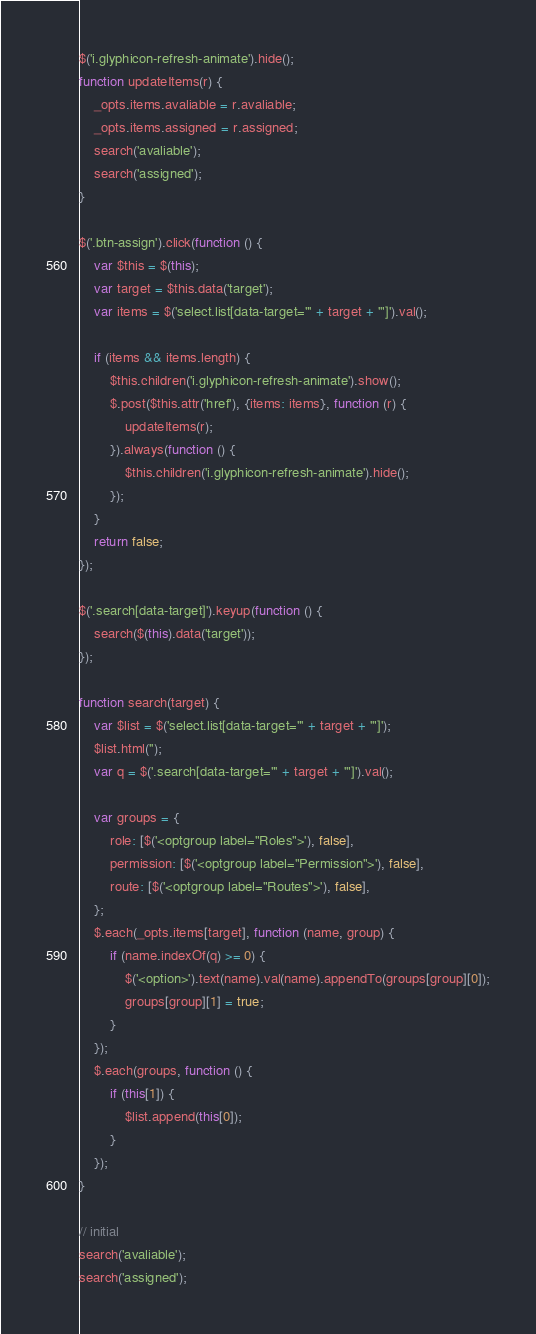<code> <loc_0><loc_0><loc_500><loc_500><_JavaScript_>$('i.glyphicon-refresh-animate').hide();
function updateItems(r) {
    _opts.items.avaliable = r.avaliable;
    _opts.items.assigned = r.assigned;
    search('avaliable');
    search('assigned');
}

$('.btn-assign').click(function () {
    var $this = $(this);
    var target = $this.data('target');
    var items = $('select.list[data-target="' + target + '"]').val();

    if (items && items.length) {
        $this.children('i.glyphicon-refresh-animate').show();
        $.post($this.attr('href'), {items: items}, function (r) {
            updateItems(r);
        }).always(function () {
            $this.children('i.glyphicon-refresh-animate').hide();
        });
    }
    return false;
});

$('.search[data-target]').keyup(function () {
    search($(this).data('target'));
});

function search(target) {
    var $list = $('select.list[data-target="' + target + '"]');
    $list.html('');
    var q = $('.search[data-target="' + target + '"]').val();

    var groups = {
        role: [$('<optgroup label="Roles">'), false],
        permission: [$('<optgroup label="Permission">'), false],
        route: [$('<optgroup label="Routes">'), false],
    };
    $.each(_opts.items[target], function (name, group) {
        if (name.indexOf(q) >= 0) {
            $('<option>').text(name).val(name).appendTo(groups[group][0]);
            groups[group][1] = true;
        }
    });
    $.each(groups, function () {
        if (this[1]) {
            $list.append(this[0]);
        }
    });
}

// initial
search('avaliable');
search('assigned');
</code> 